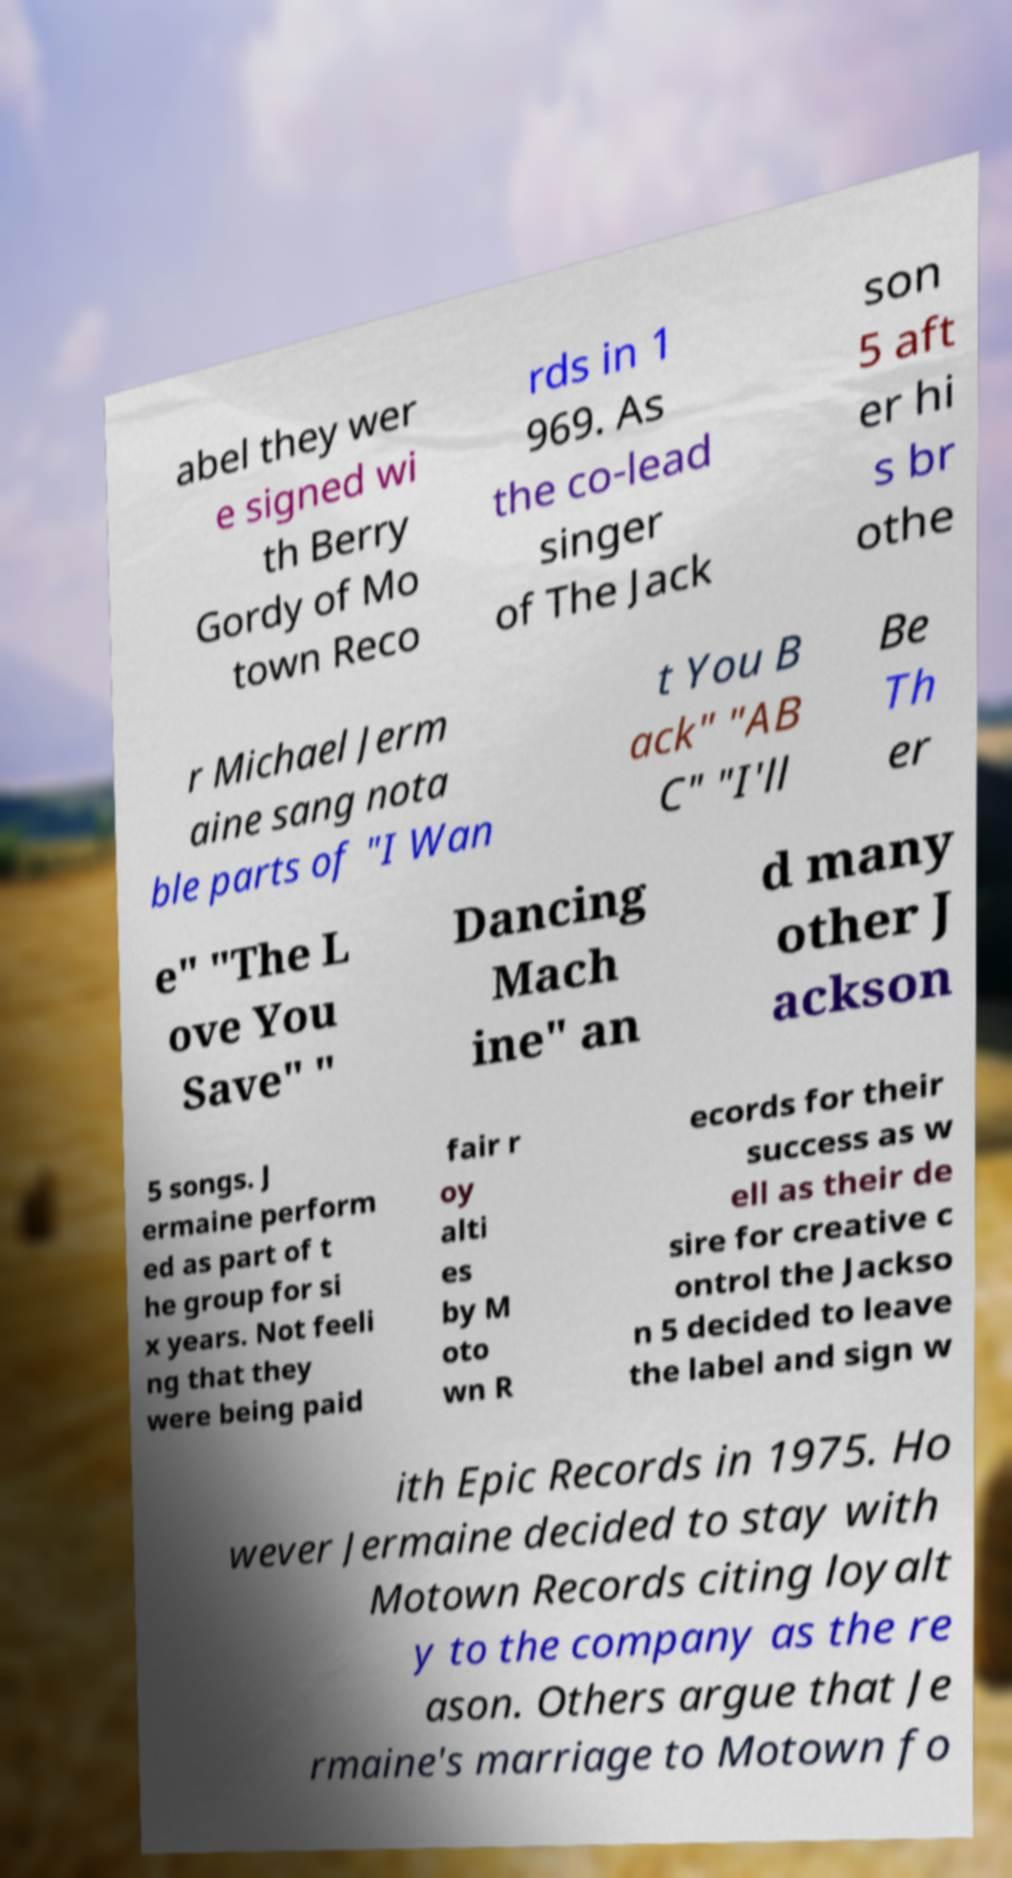Could you assist in decoding the text presented in this image and type it out clearly? abel they wer e signed wi th Berry Gordy of Mo town Reco rds in 1 969. As the co-lead singer of The Jack son 5 aft er hi s br othe r Michael Jerm aine sang nota ble parts of "I Wan t You B ack" "AB C" "I'll Be Th er e" "The L ove You Save" " Dancing Mach ine" an d many other J ackson 5 songs. J ermaine perform ed as part of t he group for si x years. Not feeli ng that they were being paid fair r oy alti es by M oto wn R ecords for their success as w ell as their de sire for creative c ontrol the Jackso n 5 decided to leave the label and sign w ith Epic Records in 1975. Ho wever Jermaine decided to stay with Motown Records citing loyalt y to the company as the re ason. Others argue that Je rmaine's marriage to Motown fo 